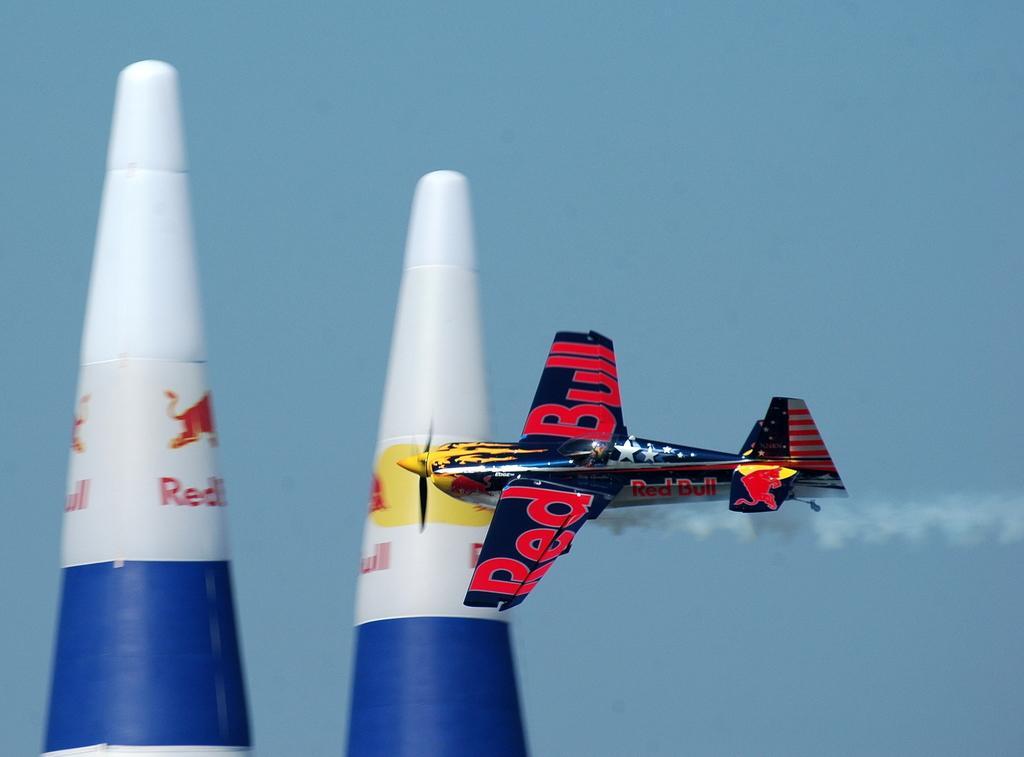Could you give a brief overview of what you see in this image? In this image, on the right side, we can see an airplane which is flying in the air. On the right side, we can also see some smoke. In the middle and on the left side, we can see two poles. In the background, we can see a sky. 